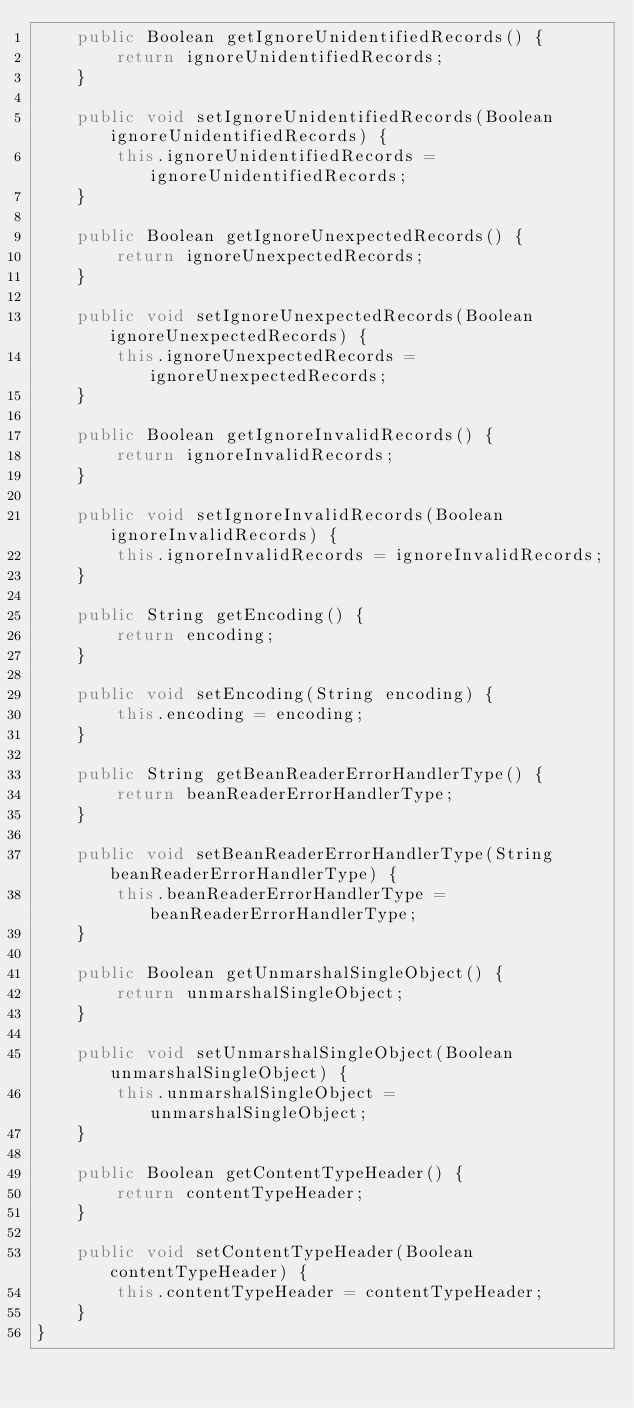Convert code to text. <code><loc_0><loc_0><loc_500><loc_500><_Java_>    public Boolean getIgnoreUnidentifiedRecords() {
        return ignoreUnidentifiedRecords;
    }

    public void setIgnoreUnidentifiedRecords(Boolean ignoreUnidentifiedRecords) {
        this.ignoreUnidentifiedRecords = ignoreUnidentifiedRecords;
    }

    public Boolean getIgnoreUnexpectedRecords() {
        return ignoreUnexpectedRecords;
    }

    public void setIgnoreUnexpectedRecords(Boolean ignoreUnexpectedRecords) {
        this.ignoreUnexpectedRecords = ignoreUnexpectedRecords;
    }

    public Boolean getIgnoreInvalidRecords() {
        return ignoreInvalidRecords;
    }

    public void setIgnoreInvalidRecords(Boolean ignoreInvalidRecords) {
        this.ignoreInvalidRecords = ignoreInvalidRecords;
    }

    public String getEncoding() {
        return encoding;
    }

    public void setEncoding(String encoding) {
        this.encoding = encoding;
    }

    public String getBeanReaderErrorHandlerType() {
        return beanReaderErrorHandlerType;
    }

    public void setBeanReaderErrorHandlerType(String beanReaderErrorHandlerType) {
        this.beanReaderErrorHandlerType = beanReaderErrorHandlerType;
    }

    public Boolean getUnmarshalSingleObject() {
        return unmarshalSingleObject;
    }

    public void setUnmarshalSingleObject(Boolean unmarshalSingleObject) {
        this.unmarshalSingleObject = unmarshalSingleObject;
    }

    public Boolean getContentTypeHeader() {
        return contentTypeHeader;
    }

    public void setContentTypeHeader(Boolean contentTypeHeader) {
        this.contentTypeHeader = contentTypeHeader;
    }
}</code> 